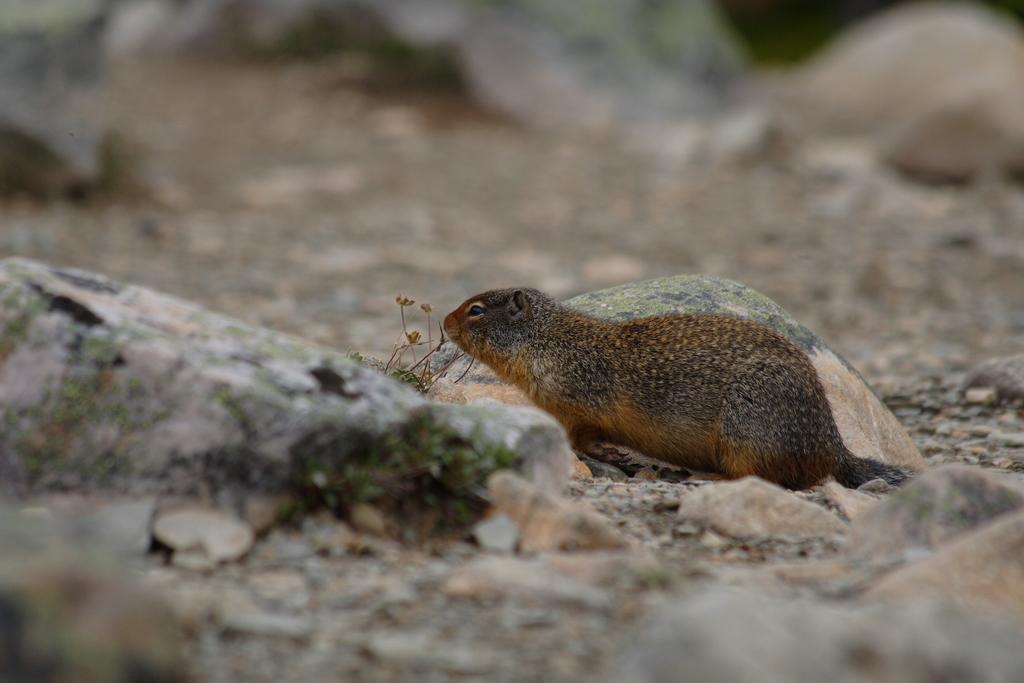In one or two sentences, can you explain what this image depicts? In this image, we can see a squirrel. There are rocks in the middle of the image. In the background, image is blurred. 